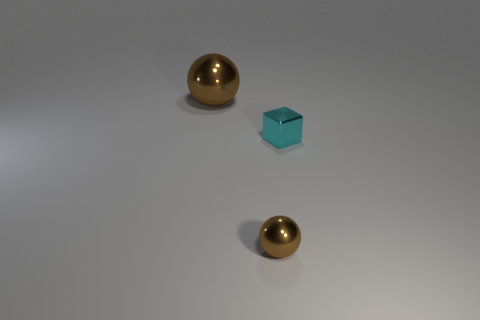What number of cylinders are small cyan metallic things or large objects?
Make the answer very short. 0. What is the shape of the tiny thing that is in front of the cyan shiny thing?
Make the answer very short. Sphere. What number of other brown things are the same material as the big brown object?
Give a very brief answer. 1. Is the number of big brown things in front of the cyan shiny thing less than the number of metallic balls?
Provide a short and direct response. Yes. There is a brown object that is behind the brown metallic thing that is on the right side of the big brown sphere; what size is it?
Make the answer very short. Large. Is the color of the block the same as the large object on the left side of the small brown metallic ball?
Your answer should be very brief. No. There is a ball that is the same size as the cyan block; what material is it?
Offer a terse response. Metal. Is the number of brown metal balls on the right side of the small brown sphere less than the number of things behind the big ball?
Your answer should be very brief. No. There is a shiny thing that is right of the brown metal thing in front of the cyan metallic thing; what shape is it?
Ensure brevity in your answer.  Cube. Are there any small cyan balls?
Make the answer very short. No. 